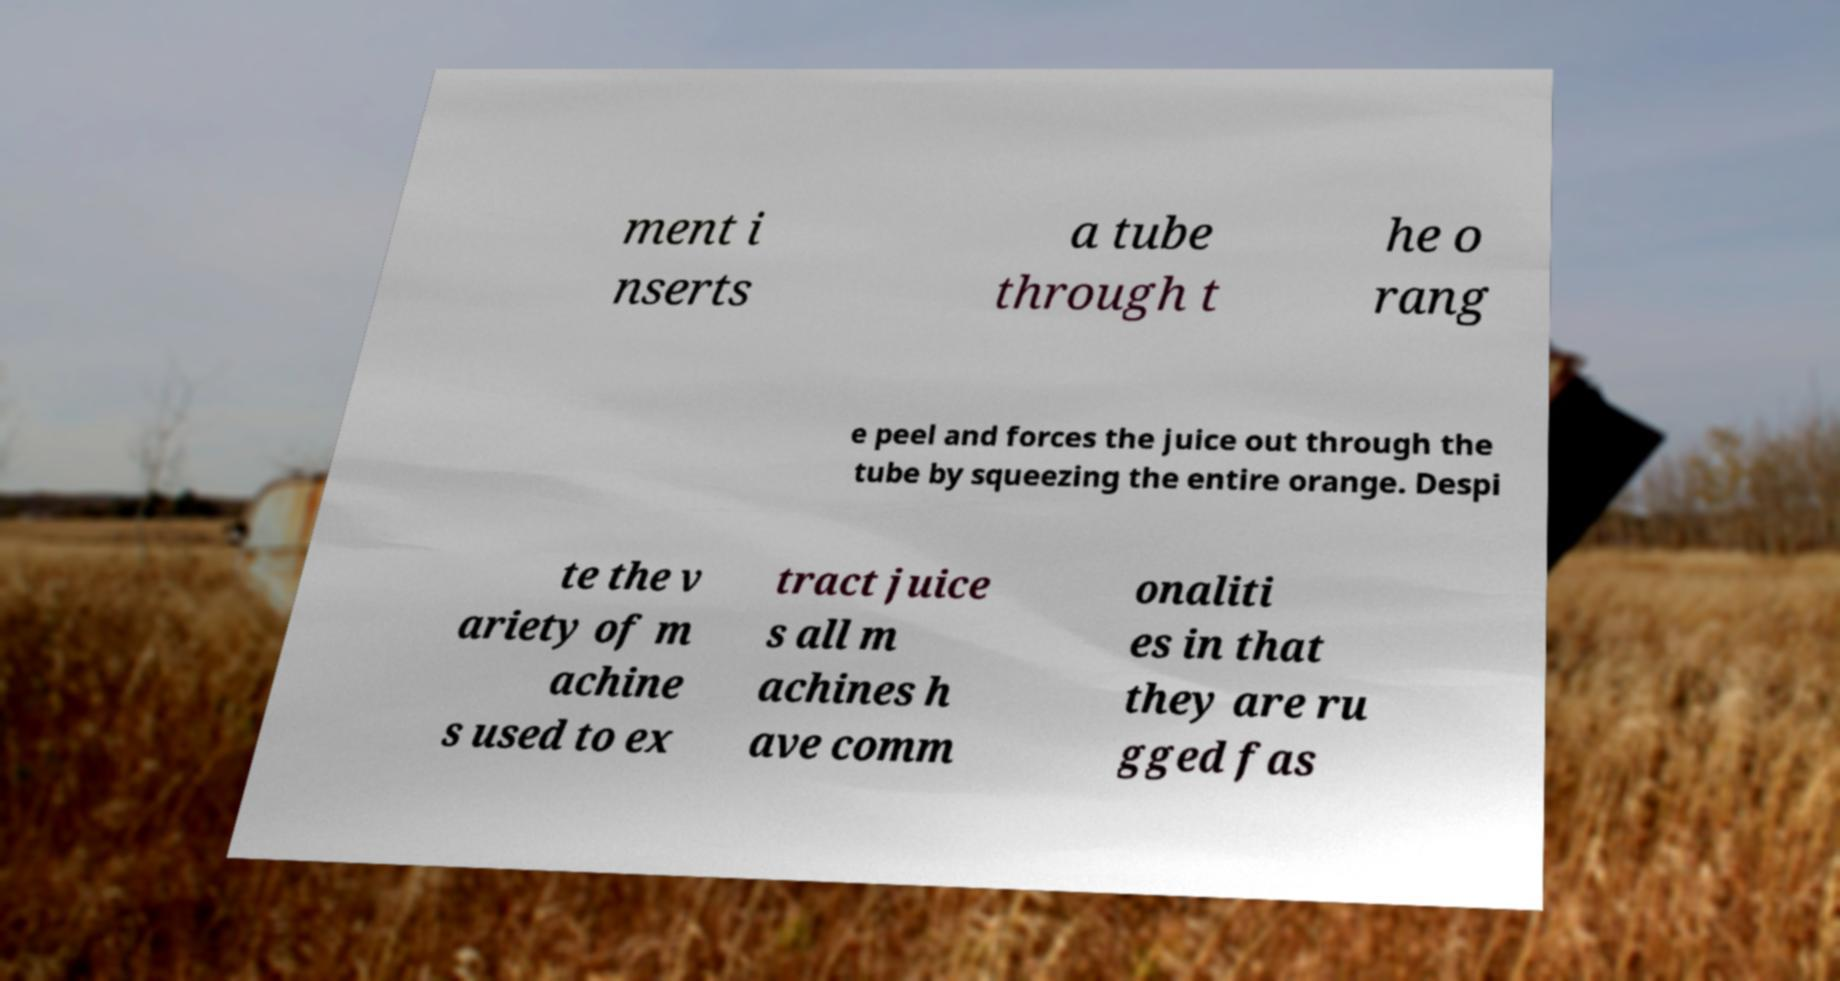Could you extract and type out the text from this image? ment i nserts a tube through t he o rang e peel and forces the juice out through the tube by squeezing the entire orange. Despi te the v ariety of m achine s used to ex tract juice s all m achines h ave comm onaliti es in that they are ru gged fas 